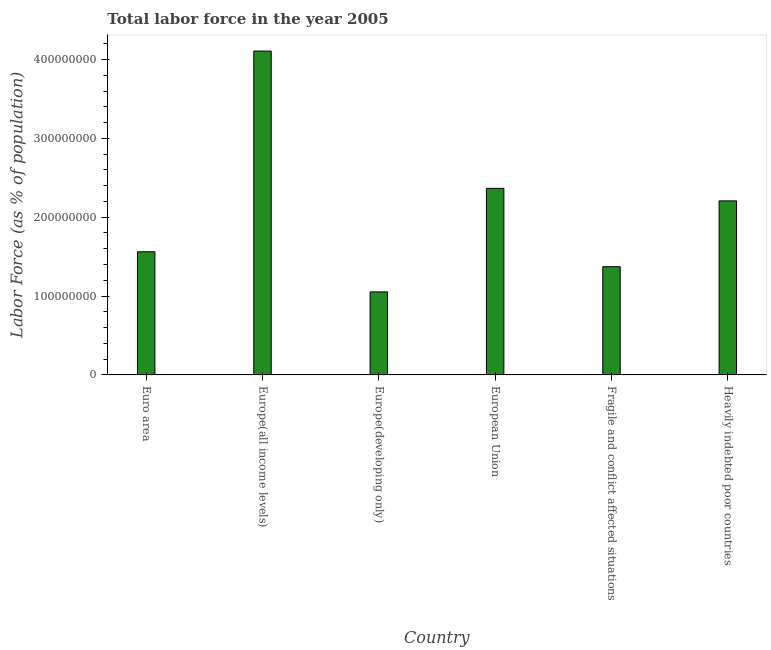Does the graph contain any zero values?
Offer a terse response. No. Does the graph contain grids?
Give a very brief answer. No. What is the title of the graph?
Give a very brief answer. Total labor force in the year 2005. What is the label or title of the X-axis?
Ensure brevity in your answer.  Country. What is the label or title of the Y-axis?
Offer a very short reply. Labor Force (as % of population). What is the total labor force in Fragile and conflict affected situations?
Provide a short and direct response. 1.37e+08. Across all countries, what is the maximum total labor force?
Offer a terse response. 4.11e+08. Across all countries, what is the minimum total labor force?
Provide a succinct answer. 1.05e+08. In which country was the total labor force maximum?
Ensure brevity in your answer.  Europe(all income levels). In which country was the total labor force minimum?
Give a very brief answer. Europe(developing only). What is the sum of the total labor force?
Make the answer very short. 1.27e+09. What is the difference between the total labor force in Euro area and Fragile and conflict affected situations?
Your answer should be compact. 1.89e+07. What is the average total labor force per country?
Your response must be concise. 2.11e+08. What is the median total labor force?
Your response must be concise. 1.88e+08. In how many countries, is the total labor force greater than 360000000 %?
Provide a short and direct response. 1. What is the ratio of the total labor force in Europe(all income levels) to that in Fragile and conflict affected situations?
Give a very brief answer. 2.99. Is the difference between the total labor force in Europe(all income levels) and Europe(developing only) greater than the difference between any two countries?
Provide a short and direct response. Yes. What is the difference between the highest and the second highest total labor force?
Offer a terse response. 1.74e+08. What is the difference between the highest and the lowest total labor force?
Give a very brief answer. 3.05e+08. How many bars are there?
Your answer should be very brief. 6. How many countries are there in the graph?
Your answer should be very brief. 6. What is the Labor Force (as % of population) in Euro area?
Give a very brief answer. 1.56e+08. What is the Labor Force (as % of population) of Europe(all income levels)?
Provide a succinct answer. 4.11e+08. What is the Labor Force (as % of population) in Europe(developing only)?
Make the answer very short. 1.05e+08. What is the Labor Force (as % of population) in European Union?
Keep it short and to the point. 2.37e+08. What is the Labor Force (as % of population) of Fragile and conflict affected situations?
Offer a terse response. 1.37e+08. What is the Labor Force (as % of population) in Heavily indebted poor countries?
Your answer should be compact. 2.21e+08. What is the difference between the Labor Force (as % of population) in Euro area and Europe(all income levels)?
Keep it short and to the point. -2.55e+08. What is the difference between the Labor Force (as % of population) in Euro area and Europe(developing only)?
Your answer should be very brief. 5.09e+07. What is the difference between the Labor Force (as % of population) in Euro area and European Union?
Give a very brief answer. -8.04e+07. What is the difference between the Labor Force (as % of population) in Euro area and Fragile and conflict affected situations?
Offer a terse response. 1.89e+07. What is the difference between the Labor Force (as % of population) in Euro area and Heavily indebted poor countries?
Keep it short and to the point. -6.45e+07. What is the difference between the Labor Force (as % of population) in Europe(all income levels) and Europe(developing only)?
Ensure brevity in your answer.  3.05e+08. What is the difference between the Labor Force (as % of population) in Europe(all income levels) and European Union?
Offer a very short reply. 1.74e+08. What is the difference between the Labor Force (as % of population) in Europe(all income levels) and Fragile and conflict affected situations?
Keep it short and to the point. 2.73e+08. What is the difference between the Labor Force (as % of population) in Europe(all income levels) and Heavily indebted poor countries?
Ensure brevity in your answer.  1.90e+08. What is the difference between the Labor Force (as % of population) in Europe(developing only) and European Union?
Provide a succinct answer. -1.31e+08. What is the difference between the Labor Force (as % of population) in Europe(developing only) and Fragile and conflict affected situations?
Ensure brevity in your answer.  -3.20e+07. What is the difference between the Labor Force (as % of population) in Europe(developing only) and Heavily indebted poor countries?
Your response must be concise. -1.15e+08. What is the difference between the Labor Force (as % of population) in European Union and Fragile and conflict affected situations?
Offer a very short reply. 9.93e+07. What is the difference between the Labor Force (as % of population) in European Union and Heavily indebted poor countries?
Keep it short and to the point. 1.59e+07. What is the difference between the Labor Force (as % of population) in Fragile and conflict affected situations and Heavily indebted poor countries?
Provide a succinct answer. -8.35e+07. What is the ratio of the Labor Force (as % of population) in Euro area to that in Europe(all income levels)?
Your response must be concise. 0.38. What is the ratio of the Labor Force (as % of population) in Euro area to that in Europe(developing only)?
Your response must be concise. 1.48. What is the ratio of the Labor Force (as % of population) in Euro area to that in European Union?
Provide a succinct answer. 0.66. What is the ratio of the Labor Force (as % of population) in Euro area to that in Fragile and conflict affected situations?
Offer a very short reply. 1.14. What is the ratio of the Labor Force (as % of population) in Euro area to that in Heavily indebted poor countries?
Keep it short and to the point. 0.71. What is the ratio of the Labor Force (as % of population) in Europe(all income levels) to that in Europe(developing only)?
Your response must be concise. 3.9. What is the ratio of the Labor Force (as % of population) in Europe(all income levels) to that in European Union?
Offer a terse response. 1.74. What is the ratio of the Labor Force (as % of population) in Europe(all income levels) to that in Fragile and conflict affected situations?
Make the answer very short. 2.99. What is the ratio of the Labor Force (as % of population) in Europe(all income levels) to that in Heavily indebted poor countries?
Your response must be concise. 1.86. What is the ratio of the Labor Force (as % of population) in Europe(developing only) to that in European Union?
Offer a terse response. 0.45. What is the ratio of the Labor Force (as % of population) in Europe(developing only) to that in Fragile and conflict affected situations?
Keep it short and to the point. 0.77. What is the ratio of the Labor Force (as % of population) in Europe(developing only) to that in Heavily indebted poor countries?
Your answer should be very brief. 0.48. What is the ratio of the Labor Force (as % of population) in European Union to that in Fragile and conflict affected situations?
Provide a short and direct response. 1.72. What is the ratio of the Labor Force (as % of population) in European Union to that in Heavily indebted poor countries?
Your answer should be very brief. 1.07. What is the ratio of the Labor Force (as % of population) in Fragile and conflict affected situations to that in Heavily indebted poor countries?
Provide a succinct answer. 0.62. 